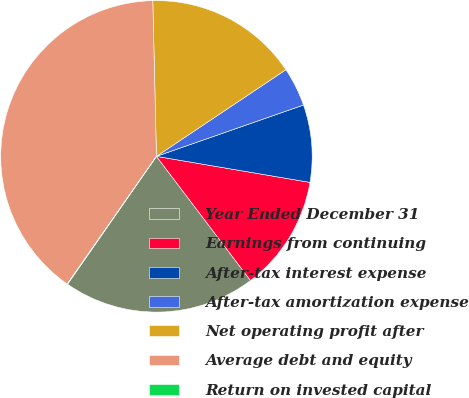<chart> <loc_0><loc_0><loc_500><loc_500><pie_chart><fcel>Year Ended December 31<fcel>Earnings from continuing<fcel>After-tax interest expense<fcel>After-tax amortization expense<fcel>Net operating profit after<fcel>Average debt and equity<fcel>Return on invested capital<nl><fcel>19.98%<fcel>12.01%<fcel>8.02%<fcel>4.04%<fcel>15.99%<fcel>39.91%<fcel>0.05%<nl></chart> 